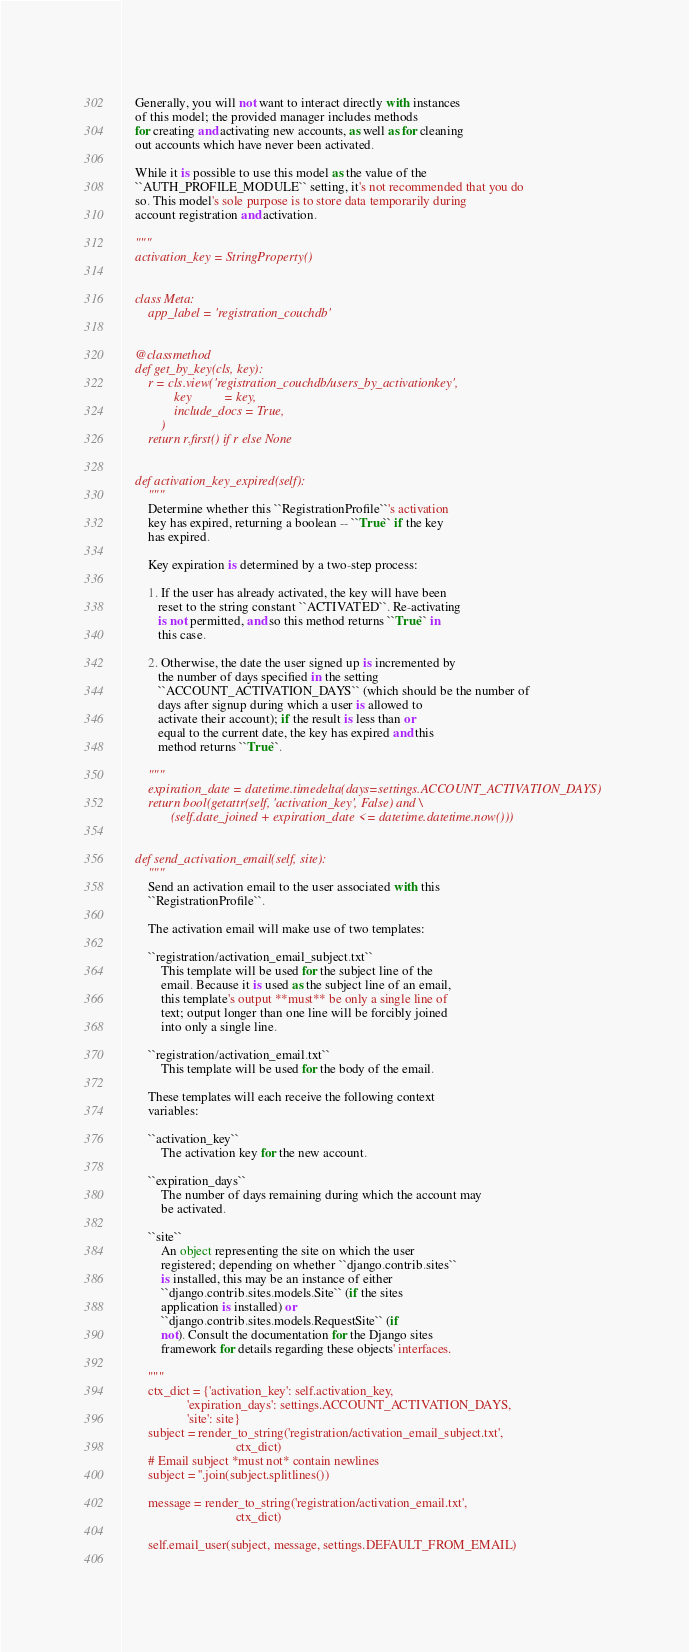Convert code to text. <code><loc_0><loc_0><loc_500><loc_500><_Python_>    
    Generally, you will not want to interact directly with instances
    of this model; the provided manager includes methods
    for creating and activating new accounts, as well as for cleaning
    out accounts which have never been activated.
    
    While it is possible to use this model as the value of the
    ``AUTH_PROFILE_MODULE`` setting, it's not recommended that you do
    so. This model's sole purpose is to store data temporarily during
    account registration and activation.
    
    """
    activation_key = StringProperty()


    class Meta:
        app_label = 'registration_couchdb'


    @classmethod
    def get_by_key(cls, key):
        r = cls.view('registration_couchdb/users_by_activationkey',
                key          = key,
                include_docs = True,
            )
        return r.first() if r else None


    def activation_key_expired(self):
        """
        Determine whether this ``RegistrationProfile``'s activation
        key has expired, returning a boolean -- ``True`` if the key
        has expired.
        
        Key expiration is determined by a two-step process:
        
        1. If the user has already activated, the key will have been
           reset to the string constant ``ACTIVATED``. Re-activating
           is not permitted, and so this method returns ``True`` in
           this case.

        2. Otherwise, the date the user signed up is incremented by
           the number of days specified in the setting
           ``ACCOUNT_ACTIVATION_DAYS`` (which should be the number of
           days after signup during which a user is allowed to
           activate their account); if the result is less than or
           equal to the current date, the key has expired and this
           method returns ``True``.
        
        """
        expiration_date = datetime.timedelta(days=settings.ACCOUNT_ACTIVATION_DAYS)
        return bool(getattr(self, 'activation_key', False) and \
               (self.date_joined + expiration_date <= datetime.datetime.now()))


    def send_activation_email(self, site):
        """
        Send an activation email to the user associated with this
        ``RegistrationProfile``.
        
        The activation email will make use of two templates:

        ``registration/activation_email_subject.txt``
            This template will be used for the subject line of the
            email. Because it is used as the subject line of an email,
            this template's output **must** be only a single line of
            text; output longer than one line will be forcibly joined
            into only a single line.

        ``registration/activation_email.txt``
            This template will be used for the body of the email.

        These templates will each receive the following context
        variables:

        ``activation_key``
            The activation key for the new account.

        ``expiration_days``
            The number of days remaining during which the account may
            be activated.

        ``site``
            An object representing the site on which the user
            registered; depending on whether ``django.contrib.sites``
            is installed, this may be an instance of either
            ``django.contrib.sites.models.Site`` (if the sites
            application is installed) or
            ``django.contrib.sites.models.RequestSite`` (if
            not). Consult the documentation for the Django sites
            framework for details regarding these objects' interfaces.

        """
        ctx_dict = {'activation_key': self.activation_key,
                    'expiration_days': settings.ACCOUNT_ACTIVATION_DAYS,
                    'site': site}
        subject = render_to_string('registration/activation_email_subject.txt',
                                   ctx_dict)
        # Email subject *must not* contain newlines
        subject = ''.join(subject.splitlines())
        
        message = render_to_string('registration/activation_email.txt',
                                   ctx_dict)
        
        self.email_user(subject, message, settings.DEFAULT_FROM_EMAIL)
    
</code> 